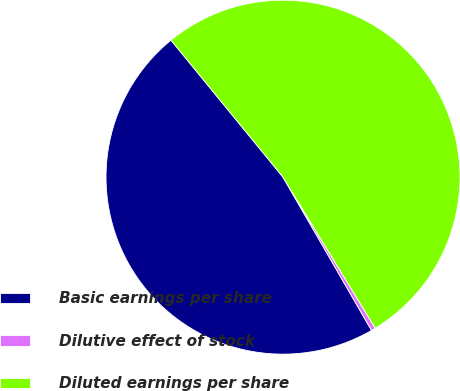Convert chart. <chart><loc_0><loc_0><loc_500><loc_500><pie_chart><fcel>Basic earnings per share<fcel>Dilutive effect of stock<fcel>Diluted earnings per share<nl><fcel>47.43%<fcel>0.39%<fcel>52.18%<nl></chart> 